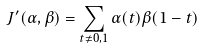<formula> <loc_0><loc_0><loc_500><loc_500>J ^ { \prime } ( \alpha , \beta ) = \sum _ { t \neq 0 , 1 } \alpha ( t ) \beta ( 1 - t )</formula> 